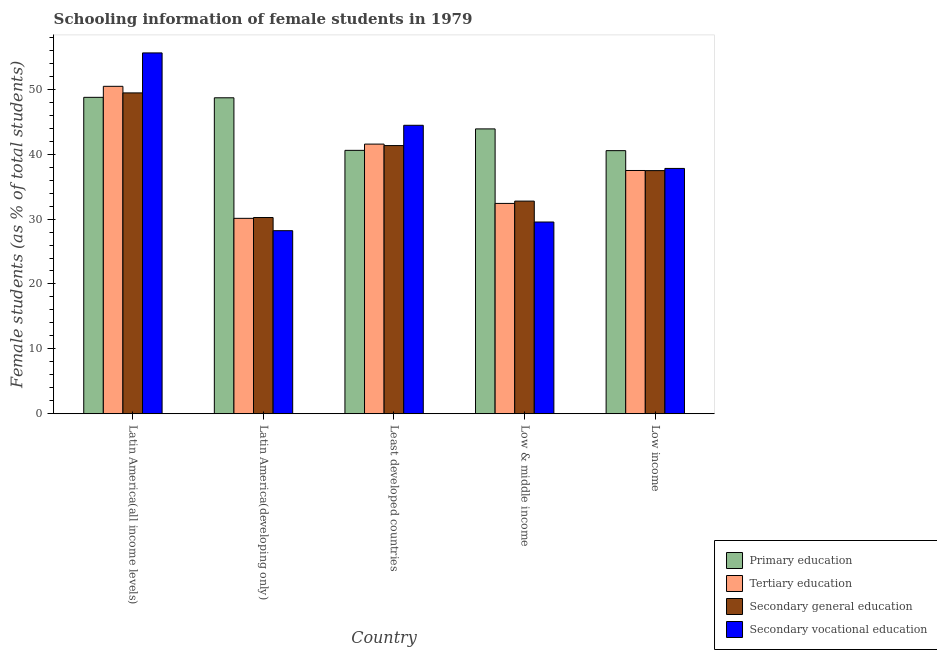How many bars are there on the 1st tick from the left?
Ensure brevity in your answer.  4. What is the label of the 3rd group of bars from the left?
Provide a succinct answer. Least developed countries. In how many cases, is the number of bars for a given country not equal to the number of legend labels?
Your answer should be very brief. 0. What is the percentage of female students in secondary vocational education in Low & middle income?
Keep it short and to the point. 29.55. Across all countries, what is the maximum percentage of female students in tertiary education?
Give a very brief answer. 50.46. Across all countries, what is the minimum percentage of female students in primary education?
Give a very brief answer. 40.54. In which country was the percentage of female students in secondary education maximum?
Offer a very short reply. Latin America(all income levels). In which country was the percentage of female students in tertiary education minimum?
Provide a short and direct response. Latin America(developing only). What is the total percentage of female students in secondary vocational education in the graph?
Your answer should be very brief. 195.62. What is the difference between the percentage of female students in secondary vocational education in Latin America(developing only) and that in Low income?
Provide a short and direct response. -9.59. What is the difference between the percentage of female students in tertiary education in Latin America(developing only) and the percentage of female students in primary education in Low income?
Your response must be concise. -10.43. What is the average percentage of female students in tertiary education per country?
Offer a terse response. 38.4. What is the difference between the percentage of female students in secondary education and percentage of female students in secondary vocational education in Latin America(all income levels)?
Your answer should be compact. -6.16. In how many countries, is the percentage of female students in secondary vocational education greater than 52 %?
Make the answer very short. 1. What is the ratio of the percentage of female students in secondary vocational education in Latin America(developing only) to that in Low & middle income?
Give a very brief answer. 0.95. Is the percentage of female students in secondary education in Latin America(all income levels) less than that in Latin America(developing only)?
Keep it short and to the point. No. What is the difference between the highest and the second highest percentage of female students in secondary vocational education?
Offer a very short reply. 11.15. What is the difference between the highest and the lowest percentage of female students in primary education?
Offer a terse response. 8.22. In how many countries, is the percentage of female students in secondary vocational education greater than the average percentage of female students in secondary vocational education taken over all countries?
Your response must be concise. 2. Is the sum of the percentage of female students in primary education in Least developed countries and Low income greater than the maximum percentage of female students in tertiary education across all countries?
Provide a succinct answer. Yes. Is it the case that in every country, the sum of the percentage of female students in secondary vocational education and percentage of female students in primary education is greater than the sum of percentage of female students in secondary education and percentage of female students in tertiary education?
Your response must be concise. No. What does the 4th bar from the left in Low income represents?
Your response must be concise. Secondary vocational education. What does the 4th bar from the right in Least developed countries represents?
Offer a very short reply. Primary education. How many bars are there?
Your answer should be very brief. 20. How many countries are there in the graph?
Offer a very short reply. 5. Are the values on the major ticks of Y-axis written in scientific E-notation?
Offer a very short reply. No. Does the graph contain grids?
Offer a very short reply. No. What is the title of the graph?
Provide a succinct answer. Schooling information of female students in 1979. Does "Energy" appear as one of the legend labels in the graph?
Keep it short and to the point. No. What is the label or title of the X-axis?
Provide a short and direct response. Country. What is the label or title of the Y-axis?
Make the answer very short. Female students (as % of total students). What is the Female students (as % of total students) of Primary education in Latin America(all income levels)?
Ensure brevity in your answer.  48.76. What is the Female students (as % of total students) of Tertiary education in Latin America(all income levels)?
Your answer should be compact. 50.46. What is the Female students (as % of total students) of Secondary general education in Latin America(all income levels)?
Give a very brief answer. 49.44. What is the Female students (as % of total students) in Secondary vocational education in Latin America(all income levels)?
Your answer should be compact. 55.61. What is the Female students (as % of total students) of Primary education in Latin America(developing only)?
Keep it short and to the point. 48.69. What is the Female students (as % of total students) in Tertiary education in Latin America(developing only)?
Your answer should be compact. 30.11. What is the Female students (as % of total students) of Secondary general education in Latin America(developing only)?
Provide a succinct answer. 30.24. What is the Female students (as % of total students) of Secondary vocational education in Latin America(developing only)?
Make the answer very short. 28.21. What is the Female students (as % of total students) of Primary education in Least developed countries?
Your response must be concise. 40.59. What is the Female students (as % of total students) of Tertiary education in Least developed countries?
Ensure brevity in your answer.  41.55. What is the Female students (as % of total students) in Secondary general education in Least developed countries?
Offer a very short reply. 41.33. What is the Female students (as % of total students) in Secondary vocational education in Least developed countries?
Your answer should be compact. 44.45. What is the Female students (as % of total students) of Primary education in Low & middle income?
Offer a very short reply. 43.9. What is the Female students (as % of total students) in Tertiary education in Low & middle income?
Make the answer very short. 32.41. What is the Female students (as % of total students) in Secondary general education in Low & middle income?
Offer a very short reply. 32.77. What is the Female students (as % of total students) of Secondary vocational education in Low & middle income?
Offer a very short reply. 29.55. What is the Female students (as % of total students) in Primary education in Low income?
Your answer should be very brief. 40.54. What is the Female students (as % of total students) of Tertiary education in Low income?
Provide a succinct answer. 37.49. What is the Female students (as % of total students) in Secondary general education in Low income?
Provide a succinct answer. 37.47. What is the Female students (as % of total students) in Secondary vocational education in Low income?
Provide a succinct answer. 37.8. Across all countries, what is the maximum Female students (as % of total students) in Primary education?
Give a very brief answer. 48.76. Across all countries, what is the maximum Female students (as % of total students) of Tertiary education?
Your response must be concise. 50.46. Across all countries, what is the maximum Female students (as % of total students) in Secondary general education?
Your response must be concise. 49.44. Across all countries, what is the maximum Female students (as % of total students) of Secondary vocational education?
Your response must be concise. 55.61. Across all countries, what is the minimum Female students (as % of total students) in Primary education?
Ensure brevity in your answer.  40.54. Across all countries, what is the minimum Female students (as % of total students) in Tertiary education?
Your answer should be compact. 30.11. Across all countries, what is the minimum Female students (as % of total students) in Secondary general education?
Your answer should be very brief. 30.24. Across all countries, what is the minimum Female students (as % of total students) of Secondary vocational education?
Keep it short and to the point. 28.21. What is the total Female students (as % of total students) of Primary education in the graph?
Keep it short and to the point. 222.48. What is the total Female students (as % of total students) of Tertiary education in the graph?
Offer a terse response. 192.02. What is the total Female students (as % of total students) in Secondary general education in the graph?
Provide a succinct answer. 191.24. What is the total Female students (as % of total students) in Secondary vocational education in the graph?
Offer a terse response. 195.62. What is the difference between the Female students (as % of total students) in Primary education in Latin America(all income levels) and that in Latin America(developing only)?
Offer a very short reply. 0.07. What is the difference between the Female students (as % of total students) in Tertiary education in Latin America(all income levels) and that in Latin America(developing only)?
Provide a succinct answer. 20.34. What is the difference between the Female students (as % of total students) of Secondary general education in Latin America(all income levels) and that in Latin America(developing only)?
Provide a succinct answer. 19.21. What is the difference between the Female students (as % of total students) of Secondary vocational education in Latin America(all income levels) and that in Latin America(developing only)?
Your response must be concise. 27.39. What is the difference between the Female students (as % of total students) of Primary education in Latin America(all income levels) and that in Least developed countries?
Keep it short and to the point. 8.17. What is the difference between the Female students (as % of total students) in Tertiary education in Latin America(all income levels) and that in Least developed countries?
Your response must be concise. 8.9. What is the difference between the Female students (as % of total students) of Secondary general education in Latin America(all income levels) and that in Least developed countries?
Give a very brief answer. 8.12. What is the difference between the Female students (as % of total students) of Secondary vocational education in Latin America(all income levels) and that in Least developed countries?
Your answer should be compact. 11.15. What is the difference between the Female students (as % of total students) of Primary education in Latin America(all income levels) and that in Low & middle income?
Offer a very short reply. 4.86. What is the difference between the Female students (as % of total students) of Tertiary education in Latin America(all income levels) and that in Low & middle income?
Offer a terse response. 18.04. What is the difference between the Female students (as % of total students) of Secondary general education in Latin America(all income levels) and that in Low & middle income?
Give a very brief answer. 16.67. What is the difference between the Female students (as % of total students) in Secondary vocational education in Latin America(all income levels) and that in Low & middle income?
Your answer should be very brief. 26.06. What is the difference between the Female students (as % of total students) in Primary education in Latin America(all income levels) and that in Low income?
Give a very brief answer. 8.22. What is the difference between the Female students (as % of total students) of Tertiary education in Latin America(all income levels) and that in Low income?
Offer a terse response. 12.97. What is the difference between the Female students (as % of total students) of Secondary general education in Latin America(all income levels) and that in Low income?
Offer a terse response. 11.98. What is the difference between the Female students (as % of total students) in Secondary vocational education in Latin America(all income levels) and that in Low income?
Give a very brief answer. 17.8. What is the difference between the Female students (as % of total students) of Primary education in Latin America(developing only) and that in Least developed countries?
Your answer should be very brief. 8.1. What is the difference between the Female students (as % of total students) of Tertiary education in Latin America(developing only) and that in Least developed countries?
Provide a short and direct response. -11.44. What is the difference between the Female students (as % of total students) in Secondary general education in Latin America(developing only) and that in Least developed countries?
Give a very brief answer. -11.09. What is the difference between the Female students (as % of total students) in Secondary vocational education in Latin America(developing only) and that in Least developed countries?
Your answer should be compact. -16.24. What is the difference between the Female students (as % of total students) in Primary education in Latin America(developing only) and that in Low & middle income?
Offer a very short reply. 4.8. What is the difference between the Female students (as % of total students) in Tertiary education in Latin America(developing only) and that in Low & middle income?
Offer a terse response. -2.3. What is the difference between the Female students (as % of total students) in Secondary general education in Latin America(developing only) and that in Low & middle income?
Offer a terse response. -2.53. What is the difference between the Female students (as % of total students) in Secondary vocational education in Latin America(developing only) and that in Low & middle income?
Offer a very short reply. -1.34. What is the difference between the Female students (as % of total students) in Primary education in Latin America(developing only) and that in Low income?
Ensure brevity in your answer.  8.15. What is the difference between the Female students (as % of total students) of Tertiary education in Latin America(developing only) and that in Low income?
Offer a terse response. -7.37. What is the difference between the Female students (as % of total students) in Secondary general education in Latin America(developing only) and that in Low income?
Make the answer very short. -7.23. What is the difference between the Female students (as % of total students) of Secondary vocational education in Latin America(developing only) and that in Low income?
Offer a terse response. -9.59. What is the difference between the Female students (as % of total students) in Primary education in Least developed countries and that in Low & middle income?
Make the answer very short. -3.31. What is the difference between the Female students (as % of total students) in Tertiary education in Least developed countries and that in Low & middle income?
Make the answer very short. 9.14. What is the difference between the Female students (as % of total students) in Secondary general education in Least developed countries and that in Low & middle income?
Give a very brief answer. 8.56. What is the difference between the Female students (as % of total students) in Secondary vocational education in Least developed countries and that in Low & middle income?
Ensure brevity in your answer.  14.91. What is the difference between the Female students (as % of total students) of Primary education in Least developed countries and that in Low income?
Your response must be concise. 0.05. What is the difference between the Female students (as % of total students) in Tertiary education in Least developed countries and that in Low income?
Provide a short and direct response. 4.07. What is the difference between the Female students (as % of total students) in Secondary general education in Least developed countries and that in Low income?
Your answer should be very brief. 3.86. What is the difference between the Female students (as % of total students) of Secondary vocational education in Least developed countries and that in Low income?
Make the answer very short. 6.65. What is the difference between the Female students (as % of total students) in Primary education in Low & middle income and that in Low income?
Give a very brief answer. 3.35. What is the difference between the Female students (as % of total students) of Tertiary education in Low & middle income and that in Low income?
Make the answer very short. -5.07. What is the difference between the Female students (as % of total students) in Secondary general education in Low & middle income and that in Low income?
Provide a short and direct response. -4.7. What is the difference between the Female students (as % of total students) of Secondary vocational education in Low & middle income and that in Low income?
Make the answer very short. -8.26. What is the difference between the Female students (as % of total students) in Primary education in Latin America(all income levels) and the Female students (as % of total students) in Tertiary education in Latin America(developing only)?
Your answer should be compact. 18.65. What is the difference between the Female students (as % of total students) of Primary education in Latin America(all income levels) and the Female students (as % of total students) of Secondary general education in Latin America(developing only)?
Keep it short and to the point. 18.52. What is the difference between the Female students (as % of total students) of Primary education in Latin America(all income levels) and the Female students (as % of total students) of Secondary vocational education in Latin America(developing only)?
Your answer should be very brief. 20.55. What is the difference between the Female students (as % of total students) in Tertiary education in Latin America(all income levels) and the Female students (as % of total students) in Secondary general education in Latin America(developing only)?
Keep it short and to the point. 20.22. What is the difference between the Female students (as % of total students) in Tertiary education in Latin America(all income levels) and the Female students (as % of total students) in Secondary vocational education in Latin America(developing only)?
Your answer should be compact. 22.25. What is the difference between the Female students (as % of total students) of Secondary general education in Latin America(all income levels) and the Female students (as % of total students) of Secondary vocational education in Latin America(developing only)?
Offer a very short reply. 21.23. What is the difference between the Female students (as % of total students) in Primary education in Latin America(all income levels) and the Female students (as % of total students) in Tertiary education in Least developed countries?
Offer a very short reply. 7.21. What is the difference between the Female students (as % of total students) in Primary education in Latin America(all income levels) and the Female students (as % of total students) in Secondary general education in Least developed countries?
Make the answer very short. 7.43. What is the difference between the Female students (as % of total students) in Primary education in Latin America(all income levels) and the Female students (as % of total students) in Secondary vocational education in Least developed countries?
Your response must be concise. 4.31. What is the difference between the Female students (as % of total students) in Tertiary education in Latin America(all income levels) and the Female students (as % of total students) in Secondary general education in Least developed countries?
Your answer should be very brief. 9.13. What is the difference between the Female students (as % of total students) of Tertiary education in Latin America(all income levels) and the Female students (as % of total students) of Secondary vocational education in Least developed countries?
Provide a short and direct response. 6. What is the difference between the Female students (as % of total students) of Secondary general education in Latin America(all income levels) and the Female students (as % of total students) of Secondary vocational education in Least developed countries?
Offer a terse response. 4.99. What is the difference between the Female students (as % of total students) in Primary education in Latin America(all income levels) and the Female students (as % of total students) in Tertiary education in Low & middle income?
Ensure brevity in your answer.  16.35. What is the difference between the Female students (as % of total students) in Primary education in Latin America(all income levels) and the Female students (as % of total students) in Secondary general education in Low & middle income?
Your response must be concise. 15.99. What is the difference between the Female students (as % of total students) of Primary education in Latin America(all income levels) and the Female students (as % of total students) of Secondary vocational education in Low & middle income?
Your answer should be compact. 19.21. What is the difference between the Female students (as % of total students) of Tertiary education in Latin America(all income levels) and the Female students (as % of total students) of Secondary general education in Low & middle income?
Give a very brief answer. 17.69. What is the difference between the Female students (as % of total students) of Tertiary education in Latin America(all income levels) and the Female students (as % of total students) of Secondary vocational education in Low & middle income?
Provide a succinct answer. 20.91. What is the difference between the Female students (as % of total students) in Secondary general education in Latin America(all income levels) and the Female students (as % of total students) in Secondary vocational education in Low & middle income?
Offer a terse response. 19.9. What is the difference between the Female students (as % of total students) in Primary education in Latin America(all income levels) and the Female students (as % of total students) in Tertiary education in Low income?
Ensure brevity in your answer.  11.27. What is the difference between the Female students (as % of total students) of Primary education in Latin America(all income levels) and the Female students (as % of total students) of Secondary general education in Low income?
Offer a very short reply. 11.29. What is the difference between the Female students (as % of total students) of Primary education in Latin America(all income levels) and the Female students (as % of total students) of Secondary vocational education in Low income?
Provide a short and direct response. 10.96. What is the difference between the Female students (as % of total students) of Tertiary education in Latin America(all income levels) and the Female students (as % of total students) of Secondary general education in Low income?
Offer a terse response. 12.99. What is the difference between the Female students (as % of total students) of Tertiary education in Latin America(all income levels) and the Female students (as % of total students) of Secondary vocational education in Low income?
Your answer should be very brief. 12.65. What is the difference between the Female students (as % of total students) of Secondary general education in Latin America(all income levels) and the Female students (as % of total students) of Secondary vocational education in Low income?
Give a very brief answer. 11.64. What is the difference between the Female students (as % of total students) of Primary education in Latin America(developing only) and the Female students (as % of total students) of Tertiary education in Least developed countries?
Your answer should be compact. 7.14. What is the difference between the Female students (as % of total students) in Primary education in Latin America(developing only) and the Female students (as % of total students) in Secondary general education in Least developed countries?
Your response must be concise. 7.37. What is the difference between the Female students (as % of total students) of Primary education in Latin America(developing only) and the Female students (as % of total students) of Secondary vocational education in Least developed countries?
Offer a terse response. 4.24. What is the difference between the Female students (as % of total students) of Tertiary education in Latin America(developing only) and the Female students (as % of total students) of Secondary general education in Least developed countries?
Give a very brief answer. -11.21. What is the difference between the Female students (as % of total students) in Tertiary education in Latin America(developing only) and the Female students (as % of total students) in Secondary vocational education in Least developed countries?
Offer a very short reply. -14.34. What is the difference between the Female students (as % of total students) in Secondary general education in Latin America(developing only) and the Female students (as % of total students) in Secondary vocational education in Least developed countries?
Keep it short and to the point. -14.21. What is the difference between the Female students (as % of total students) of Primary education in Latin America(developing only) and the Female students (as % of total students) of Tertiary education in Low & middle income?
Your answer should be very brief. 16.28. What is the difference between the Female students (as % of total students) of Primary education in Latin America(developing only) and the Female students (as % of total students) of Secondary general education in Low & middle income?
Keep it short and to the point. 15.92. What is the difference between the Female students (as % of total students) in Primary education in Latin America(developing only) and the Female students (as % of total students) in Secondary vocational education in Low & middle income?
Your answer should be compact. 19.14. What is the difference between the Female students (as % of total students) in Tertiary education in Latin America(developing only) and the Female students (as % of total students) in Secondary general education in Low & middle income?
Your answer should be compact. -2.66. What is the difference between the Female students (as % of total students) of Tertiary education in Latin America(developing only) and the Female students (as % of total students) of Secondary vocational education in Low & middle income?
Make the answer very short. 0.57. What is the difference between the Female students (as % of total students) of Secondary general education in Latin America(developing only) and the Female students (as % of total students) of Secondary vocational education in Low & middle income?
Ensure brevity in your answer.  0.69. What is the difference between the Female students (as % of total students) in Primary education in Latin America(developing only) and the Female students (as % of total students) in Tertiary education in Low income?
Offer a very short reply. 11.2. What is the difference between the Female students (as % of total students) in Primary education in Latin America(developing only) and the Female students (as % of total students) in Secondary general education in Low income?
Provide a short and direct response. 11.22. What is the difference between the Female students (as % of total students) in Primary education in Latin America(developing only) and the Female students (as % of total students) in Secondary vocational education in Low income?
Make the answer very short. 10.89. What is the difference between the Female students (as % of total students) in Tertiary education in Latin America(developing only) and the Female students (as % of total students) in Secondary general education in Low income?
Ensure brevity in your answer.  -7.35. What is the difference between the Female students (as % of total students) of Tertiary education in Latin America(developing only) and the Female students (as % of total students) of Secondary vocational education in Low income?
Give a very brief answer. -7.69. What is the difference between the Female students (as % of total students) in Secondary general education in Latin America(developing only) and the Female students (as % of total students) in Secondary vocational education in Low income?
Your answer should be compact. -7.57. What is the difference between the Female students (as % of total students) in Primary education in Least developed countries and the Female students (as % of total students) in Tertiary education in Low & middle income?
Provide a short and direct response. 8.18. What is the difference between the Female students (as % of total students) in Primary education in Least developed countries and the Female students (as % of total students) in Secondary general education in Low & middle income?
Provide a succinct answer. 7.82. What is the difference between the Female students (as % of total students) of Primary education in Least developed countries and the Female students (as % of total students) of Secondary vocational education in Low & middle income?
Your answer should be very brief. 11.04. What is the difference between the Female students (as % of total students) in Tertiary education in Least developed countries and the Female students (as % of total students) in Secondary general education in Low & middle income?
Make the answer very short. 8.78. What is the difference between the Female students (as % of total students) in Tertiary education in Least developed countries and the Female students (as % of total students) in Secondary vocational education in Low & middle income?
Your answer should be compact. 12.01. What is the difference between the Female students (as % of total students) of Secondary general education in Least developed countries and the Female students (as % of total students) of Secondary vocational education in Low & middle income?
Provide a succinct answer. 11.78. What is the difference between the Female students (as % of total students) of Primary education in Least developed countries and the Female students (as % of total students) of Tertiary education in Low income?
Make the answer very short. 3.1. What is the difference between the Female students (as % of total students) in Primary education in Least developed countries and the Female students (as % of total students) in Secondary general education in Low income?
Your answer should be very brief. 3.12. What is the difference between the Female students (as % of total students) in Primary education in Least developed countries and the Female students (as % of total students) in Secondary vocational education in Low income?
Your answer should be very brief. 2.79. What is the difference between the Female students (as % of total students) of Tertiary education in Least developed countries and the Female students (as % of total students) of Secondary general education in Low income?
Your response must be concise. 4.09. What is the difference between the Female students (as % of total students) of Tertiary education in Least developed countries and the Female students (as % of total students) of Secondary vocational education in Low income?
Your answer should be compact. 3.75. What is the difference between the Female students (as % of total students) of Secondary general education in Least developed countries and the Female students (as % of total students) of Secondary vocational education in Low income?
Your answer should be very brief. 3.52. What is the difference between the Female students (as % of total students) in Primary education in Low & middle income and the Female students (as % of total students) in Tertiary education in Low income?
Your response must be concise. 6.41. What is the difference between the Female students (as % of total students) in Primary education in Low & middle income and the Female students (as % of total students) in Secondary general education in Low income?
Make the answer very short. 6.43. What is the difference between the Female students (as % of total students) in Primary education in Low & middle income and the Female students (as % of total students) in Secondary vocational education in Low income?
Keep it short and to the point. 6.09. What is the difference between the Female students (as % of total students) in Tertiary education in Low & middle income and the Female students (as % of total students) in Secondary general education in Low income?
Make the answer very short. -5.06. What is the difference between the Female students (as % of total students) of Tertiary education in Low & middle income and the Female students (as % of total students) of Secondary vocational education in Low income?
Offer a terse response. -5.39. What is the difference between the Female students (as % of total students) in Secondary general education in Low & middle income and the Female students (as % of total students) in Secondary vocational education in Low income?
Ensure brevity in your answer.  -5.04. What is the average Female students (as % of total students) of Primary education per country?
Your response must be concise. 44.5. What is the average Female students (as % of total students) in Tertiary education per country?
Provide a succinct answer. 38.4. What is the average Female students (as % of total students) in Secondary general education per country?
Your answer should be very brief. 38.25. What is the average Female students (as % of total students) of Secondary vocational education per country?
Keep it short and to the point. 39.12. What is the difference between the Female students (as % of total students) in Primary education and Female students (as % of total students) in Tertiary education in Latin America(all income levels)?
Your answer should be very brief. -1.7. What is the difference between the Female students (as % of total students) in Primary education and Female students (as % of total students) in Secondary general education in Latin America(all income levels)?
Give a very brief answer. -0.68. What is the difference between the Female students (as % of total students) in Primary education and Female students (as % of total students) in Secondary vocational education in Latin America(all income levels)?
Ensure brevity in your answer.  -6.85. What is the difference between the Female students (as % of total students) in Tertiary education and Female students (as % of total students) in Secondary general education in Latin America(all income levels)?
Offer a very short reply. 1.01. What is the difference between the Female students (as % of total students) in Tertiary education and Female students (as % of total students) in Secondary vocational education in Latin America(all income levels)?
Offer a very short reply. -5.15. What is the difference between the Female students (as % of total students) of Secondary general education and Female students (as % of total students) of Secondary vocational education in Latin America(all income levels)?
Your answer should be compact. -6.16. What is the difference between the Female students (as % of total students) in Primary education and Female students (as % of total students) in Tertiary education in Latin America(developing only)?
Offer a terse response. 18.58. What is the difference between the Female students (as % of total students) in Primary education and Female students (as % of total students) in Secondary general education in Latin America(developing only)?
Offer a terse response. 18.45. What is the difference between the Female students (as % of total students) in Primary education and Female students (as % of total students) in Secondary vocational education in Latin America(developing only)?
Provide a short and direct response. 20.48. What is the difference between the Female students (as % of total students) of Tertiary education and Female students (as % of total students) of Secondary general education in Latin America(developing only)?
Make the answer very short. -0.13. What is the difference between the Female students (as % of total students) of Tertiary education and Female students (as % of total students) of Secondary vocational education in Latin America(developing only)?
Ensure brevity in your answer.  1.9. What is the difference between the Female students (as % of total students) of Secondary general education and Female students (as % of total students) of Secondary vocational education in Latin America(developing only)?
Offer a terse response. 2.03. What is the difference between the Female students (as % of total students) in Primary education and Female students (as % of total students) in Tertiary education in Least developed countries?
Make the answer very short. -0.96. What is the difference between the Female students (as % of total students) of Primary education and Female students (as % of total students) of Secondary general education in Least developed countries?
Your response must be concise. -0.74. What is the difference between the Female students (as % of total students) in Primary education and Female students (as % of total students) in Secondary vocational education in Least developed countries?
Offer a very short reply. -3.86. What is the difference between the Female students (as % of total students) of Tertiary education and Female students (as % of total students) of Secondary general education in Least developed countries?
Offer a terse response. 0.23. What is the difference between the Female students (as % of total students) of Tertiary education and Female students (as % of total students) of Secondary vocational education in Least developed countries?
Your answer should be compact. -2.9. What is the difference between the Female students (as % of total students) of Secondary general education and Female students (as % of total students) of Secondary vocational education in Least developed countries?
Give a very brief answer. -3.13. What is the difference between the Female students (as % of total students) of Primary education and Female students (as % of total students) of Tertiary education in Low & middle income?
Give a very brief answer. 11.48. What is the difference between the Female students (as % of total students) of Primary education and Female students (as % of total students) of Secondary general education in Low & middle income?
Offer a very short reply. 11.13. What is the difference between the Female students (as % of total students) in Primary education and Female students (as % of total students) in Secondary vocational education in Low & middle income?
Provide a short and direct response. 14.35. What is the difference between the Female students (as % of total students) in Tertiary education and Female students (as % of total students) in Secondary general education in Low & middle income?
Provide a short and direct response. -0.36. What is the difference between the Female students (as % of total students) in Tertiary education and Female students (as % of total students) in Secondary vocational education in Low & middle income?
Make the answer very short. 2.87. What is the difference between the Female students (as % of total students) of Secondary general education and Female students (as % of total students) of Secondary vocational education in Low & middle income?
Keep it short and to the point. 3.22. What is the difference between the Female students (as % of total students) in Primary education and Female students (as % of total students) in Tertiary education in Low income?
Provide a short and direct response. 3.06. What is the difference between the Female students (as % of total students) in Primary education and Female students (as % of total students) in Secondary general education in Low income?
Offer a very short reply. 3.08. What is the difference between the Female students (as % of total students) in Primary education and Female students (as % of total students) in Secondary vocational education in Low income?
Your answer should be compact. 2.74. What is the difference between the Female students (as % of total students) of Tertiary education and Female students (as % of total students) of Secondary general education in Low income?
Offer a very short reply. 0.02. What is the difference between the Female students (as % of total students) of Tertiary education and Female students (as % of total students) of Secondary vocational education in Low income?
Keep it short and to the point. -0.32. What is the difference between the Female students (as % of total students) of Secondary general education and Female students (as % of total students) of Secondary vocational education in Low income?
Make the answer very short. -0.34. What is the ratio of the Female students (as % of total students) of Primary education in Latin America(all income levels) to that in Latin America(developing only)?
Give a very brief answer. 1. What is the ratio of the Female students (as % of total students) in Tertiary education in Latin America(all income levels) to that in Latin America(developing only)?
Your answer should be compact. 1.68. What is the ratio of the Female students (as % of total students) in Secondary general education in Latin America(all income levels) to that in Latin America(developing only)?
Offer a very short reply. 1.64. What is the ratio of the Female students (as % of total students) of Secondary vocational education in Latin America(all income levels) to that in Latin America(developing only)?
Provide a short and direct response. 1.97. What is the ratio of the Female students (as % of total students) in Primary education in Latin America(all income levels) to that in Least developed countries?
Provide a succinct answer. 1.2. What is the ratio of the Female students (as % of total students) in Tertiary education in Latin America(all income levels) to that in Least developed countries?
Ensure brevity in your answer.  1.21. What is the ratio of the Female students (as % of total students) of Secondary general education in Latin America(all income levels) to that in Least developed countries?
Provide a short and direct response. 1.2. What is the ratio of the Female students (as % of total students) in Secondary vocational education in Latin America(all income levels) to that in Least developed countries?
Ensure brevity in your answer.  1.25. What is the ratio of the Female students (as % of total students) of Primary education in Latin America(all income levels) to that in Low & middle income?
Offer a very short reply. 1.11. What is the ratio of the Female students (as % of total students) in Tertiary education in Latin America(all income levels) to that in Low & middle income?
Keep it short and to the point. 1.56. What is the ratio of the Female students (as % of total students) in Secondary general education in Latin America(all income levels) to that in Low & middle income?
Keep it short and to the point. 1.51. What is the ratio of the Female students (as % of total students) in Secondary vocational education in Latin America(all income levels) to that in Low & middle income?
Ensure brevity in your answer.  1.88. What is the ratio of the Female students (as % of total students) of Primary education in Latin America(all income levels) to that in Low income?
Keep it short and to the point. 1.2. What is the ratio of the Female students (as % of total students) of Tertiary education in Latin America(all income levels) to that in Low income?
Give a very brief answer. 1.35. What is the ratio of the Female students (as % of total students) in Secondary general education in Latin America(all income levels) to that in Low income?
Provide a succinct answer. 1.32. What is the ratio of the Female students (as % of total students) of Secondary vocational education in Latin America(all income levels) to that in Low income?
Keep it short and to the point. 1.47. What is the ratio of the Female students (as % of total students) in Primary education in Latin America(developing only) to that in Least developed countries?
Your answer should be compact. 1.2. What is the ratio of the Female students (as % of total students) of Tertiary education in Latin America(developing only) to that in Least developed countries?
Offer a terse response. 0.72. What is the ratio of the Female students (as % of total students) in Secondary general education in Latin America(developing only) to that in Least developed countries?
Offer a terse response. 0.73. What is the ratio of the Female students (as % of total students) of Secondary vocational education in Latin America(developing only) to that in Least developed countries?
Your answer should be very brief. 0.63. What is the ratio of the Female students (as % of total students) in Primary education in Latin America(developing only) to that in Low & middle income?
Your answer should be very brief. 1.11. What is the ratio of the Female students (as % of total students) in Tertiary education in Latin America(developing only) to that in Low & middle income?
Give a very brief answer. 0.93. What is the ratio of the Female students (as % of total students) of Secondary general education in Latin America(developing only) to that in Low & middle income?
Provide a succinct answer. 0.92. What is the ratio of the Female students (as % of total students) in Secondary vocational education in Latin America(developing only) to that in Low & middle income?
Give a very brief answer. 0.95. What is the ratio of the Female students (as % of total students) of Primary education in Latin America(developing only) to that in Low income?
Your answer should be very brief. 1.2. What is the ratio of the Female students (as % of total students) in Tertiary education in Latin America(developing only) to that in Low income?
Keep it short and to the point. 0.8. What is the ratio of the Female students (as % of total students) in Secondary general education in Latin America(developing only) to that in Low income?
Your answer should be compact. 0.81. What is the ratio of the Female students (as % of total students) in Secondary vocational education in Latin America(developing only) to that in Low income?
Keep it short and to the point. 0.75. What is the ratio of the Female students (as % of total students) in Primary education in Least developed countries to that in Low & middle income?
Your answer should be very brief. 0.92. What is the ratio of the Female students (as % of total students) of Tertiary education in Least developed countries to that in Low & middle income?
Keep it short and to the point. 1.28. What is the ratio of the Female students (as % of total students) of Secondary general education in Least developed countries to that in Low & middle income?
Ensure brevity in your answer.  1.26. What is the ratio of the Female students (as % of total students) of Secondary vocational education in Least developed countries to that in Low & middle income?
Your answer should be compact. 1.5. What is the ratio of the Female students (as % of total students) in Primary education in Least developed countries to that in Low income?
Provide a succinct answer. 1. What is the ratio of the Female students (as % of total students) in Tertiary education in Least developed countries to that in Low income?
Provide a succinct answer. 1.11. What is the ratio of the Female students (as % of total students) in Secondary general education in Least developed countries to that in Low income?
Offer a very short reply. 1.1. What is the ratio of the Female students (as % of total students) in Secondary vocational education in Least developed countries to that in Low income?
Your answer should be compact. 1.18. What is the ratio of the Female students (as % of total students) of Primary education in Low & middle income to that in Low income?
Provide a succinct answer. 1.08. What is the ratio of the Female students (as % of total students) of Tertiary education in Low & middle income to that in Low income?
Keep it short and to the point. 0.86. What is the ratio of the Female students (as % of total students) of Secondary general education in Low & middle income to that in Low income?
Your answer should be very brief. 0.87. What is the ratio of the Female students (as % of total students) in Secondary vocational education in Low & middle income to that in Low income?
Keep it short and to the point. 0.78. What is the difference between the highest and the second highest Female students (as % of total students) in Primary education?
Offer a very short reply. 0.07. What is the difference between the highest and the second highest Female students (as % of total students) in Tertiary education?
Offer a very short reply. 8.9. What is the difference between the highest and the second highest Female students (as % of total students) of Secondary general education?
Your response must be concise. 8.12. What is the difference between the highest and the second highest Female students (as % of total students) in Secondary vocational education?
Offer a very short reply. 11.15. What is the difference between the highest and the lowest Female students (as % of total students) of Primary education?
Your answer should be compact. 8.22. What is the difference between the highest and the lowest Female students (as % of total students) in Tertiary education?
Give a very brief answer. 20.34. What is the difference between the highest and the lowest Female students (as % of total students) in Secondary general education?
Give a very brief answer. 19.21. What is the difference between the highest and the lowest Female students (as % of total students) of Secondary vocational education?
Keep it short and to the point. 27.39. 